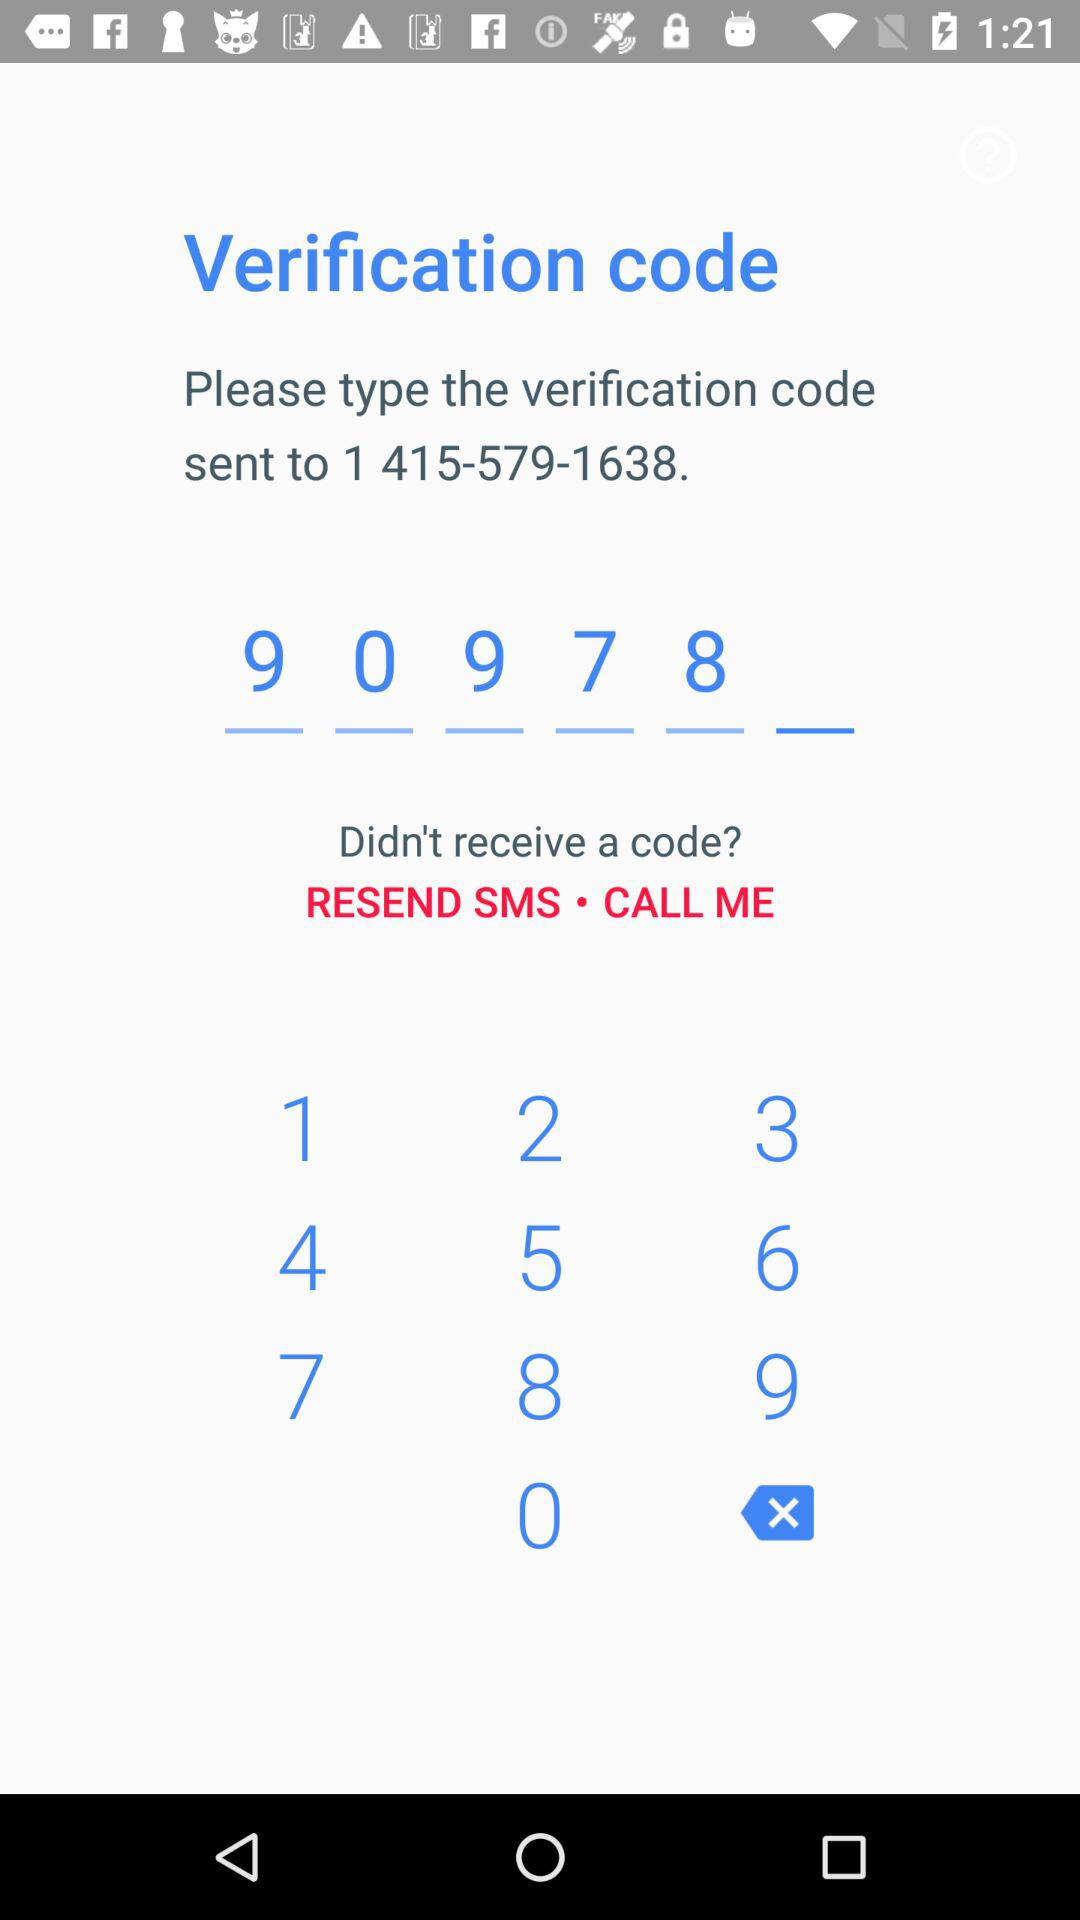When was the verification code sent?
When the provided information is insufficient, respond with <no answer>. <no answer> 